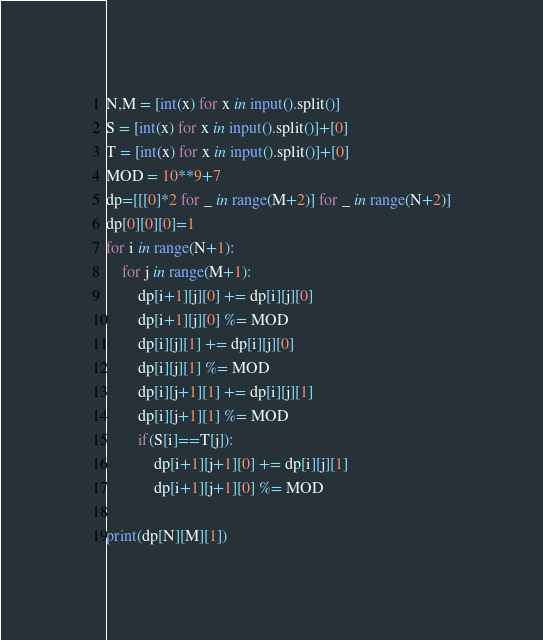Convert code to text. <code><loc_0><loc_0><loc_500><loc_500><_Python_>N,M = [int(x) for x in input().split()]
S = [int(x) for x in input().split()]+[0]
T = [int(x) for x in input().split()]+[0]
MOD = 10**9+7
dp=[[[0]*2 for _ in range(M+2)] for _ in range(N+2)]
dp[0][0][0]=1
for i in range(N+1):
    for j in range(M+1):
        dp[i+1][j][0] += dp[i][j][0]
        dp[i+1][j][0] %= MOD
        dp[i][j][1] += dp[i][j][0]
        dp[i][j][1] %= MOD
        dp[i][j+1][1] += dp[i][j][1]
        dp[i][j+1][1] %= MOD
        if(S[i]==T[j]):
            dp[i+1][j+1][0] += dp[i][j][1]
            dp[i+1][j+1][0] %= MOD

print(dp[N][M][1])
</code> 